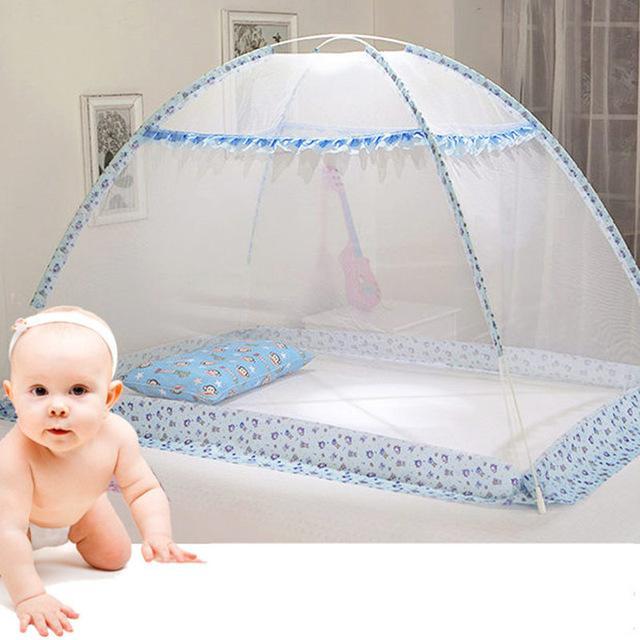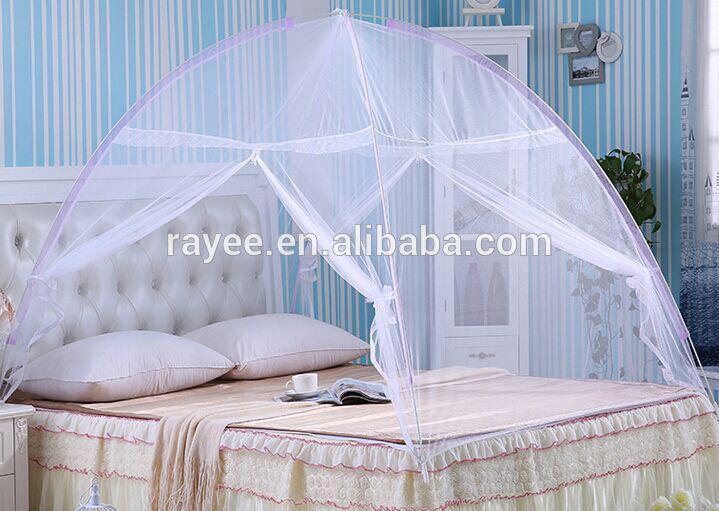The first image is the image on the left, the second image is the image on the right. Analyze the images presented: Is the assertion "There are two tent canopies with at least one with blue trim that has a pattern around the bottom of the tent." valid? Answer yes or no. Yes. The first image is the image on the left, the second image is the image on the right. Analyze the images presented: Is the assertion "In the right image exactly one net has a cloth trim on the bottom." valid? Answer yes or no. No. 